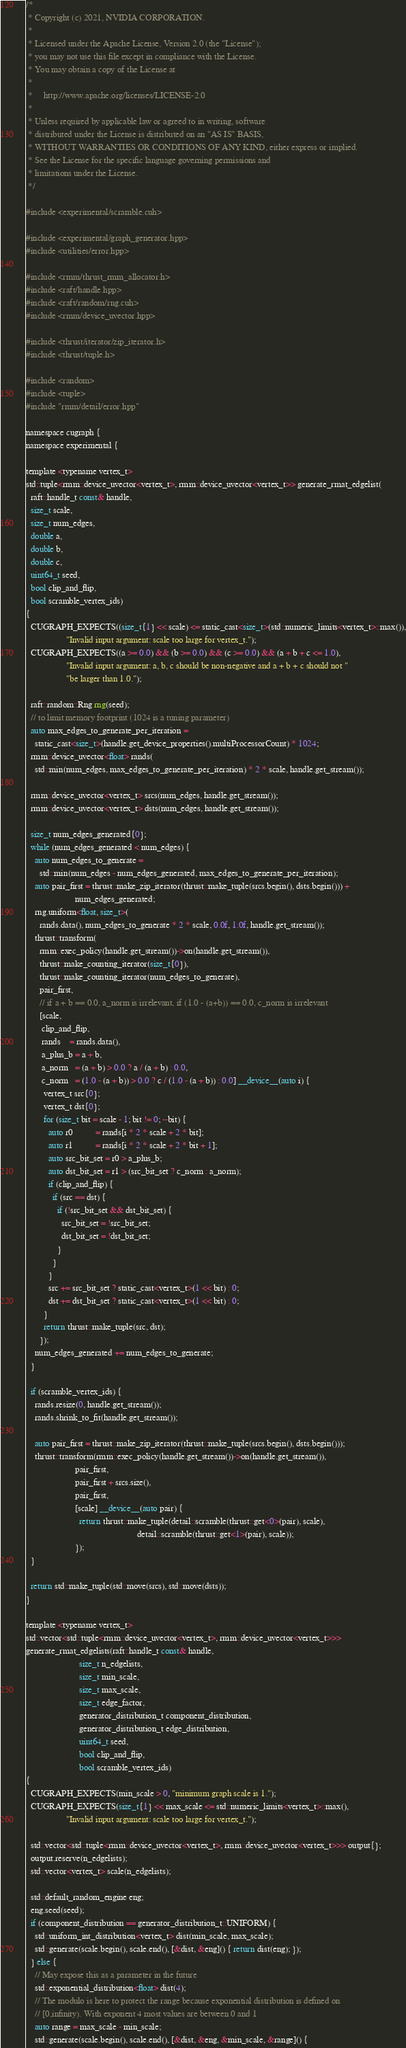<code> <loc_0><loc_0><loc_500><loc_500><_Cuda_>/*
 * Copyright (c) 2021, NVIDIA CORPORATION.
 *
 * Licensed under the Apache License, Version 2.0 (the "License");
 * you may not use this file except in compliance with the License.
 * You may obtain a copy of the License at
 *
 *     http://www.apache.org/licenses/LICENSE-2.0
 *
 * Unless required by applicable law or agreed to in writing, software
 * distributed under the License is distributed on an "AS IS" BASIS,
 * WITHOUT WARRANTIES OR CONDITIONS OF ANY KIND, either express or implied.
 * See the License for the specific language governing permissions and
 * limitations under the License.
 */

#include <experimental/scramble.cuh>

#include <experimental/graph_generator.hpp>
#include <utilities/error.hpp>

#include <rmm/thrust_rmm_allocator.h>
#include <raft/handle.hpp>
#include <raft/random/rng.cuh>
#include <rmm/device_uvector.hpp>

#include <thrust/iterator/zip_iterator.h>
#include <thrust/tuple.h>

#include <random>
#include <tuple>
#include "rmm/detail/error.hpp"

namespace cugraph {
namespace experimental {

template <typename vertex_t>
std::tuple<rmm::device_uvector<vertex_t>, rmm::device_uvector<vertex_t>> generate_rmat_edgelist(
  raft::handle_t const& handle,
  size_t scale,
  size_t num_edges,
  double a,
  double b,
  double c,
  uint64_t seed,
  bool clip_and_flip,
  bool scramble_vertex_ids)
{
  CUGRAPH_EXPECTS((size_t{1} << scale) <= static_cast<size_t>(std::numeric_limits<vertex_t>::max()),
                  "Invalid input argument: scale too large for vertex_t.");
  CUGRAPH_EXPECTS((a >= 0.0) && (b >= 0.0) && (c >= 0.0) && (a + b + c <= 1.0),
                  "Invalid input argument: a, b, c should be non-negative and a + b + c should not "
                  "be larger than 1.0.");

  raft::random::Rng rng(seed);
  // to limit memory footprint (1024 is a tuning parameter)
  auto max_edges_to_generate_per_iteration =
    static_cast<size_t>(handle.get_device_properties().multiProcessorCount) * 1024;
  rmm::device_uvector<float> rands(
    std::min(num_edges, max_edges_to_generate_per_iteration) * 2 * scale, handle.get_stream());

  rmm::device_uvector<vertex_t> srcs(num_edges, handle.get_stream());
  rmm::device_uvector<vertex_t> dsts(num_edges, handle.get_stream());

  size_t num_edges_generated{0};
  while (num_edges_generated < num_edges) {
    auto num_edges_to_generate =
      std::min(num_edges - num_edges_generated, max_edges_to_generate_per_iteration);
    auto pair_first = thrust::make_zip_iterator(thrust::make_tuple(srcs.begin(), dsts.begin())) +
                      num_edges_generated;
    rng.uniform<float, size_t>(
      rands.data(), num_edges_to_generate * 2 * scale, 0.0f, 1.0f, handle.get_stream());
    thrust::transform(
      rmm::exec_policy(handle.get_stream())->on(handle.get_stream()),
      thrust::make_counting_iterator(size_t{0}),
      thrust::make_counting_iterator(num_edges_to_generate),
      pair_first,
      // if a + b == 0.0, a_norm is irrelevant, if (1.0 - (a+b)) == 0.0, c_norm is irrelevant
      [scale,
       clip_and_flip,
       rands    = rands.data(),
       a_plus_b = a + b,
       a_norm   = (a + b) > 0.0 ? a / (a + b) : 0.0,
       c_norm   = (1.0 - (a + b)) > 0.0 ? c / (1.0 - (a + b)) : 0.0] __device__(auto i) {
        vertex_t src{0};
        vertex_t dst{0};
        for (size_t bit = scale - 1; bit != 0; --bit) {
          auto r0          = rands[i * 2 * scale + 2 * bit];
          auto r1          = rands[i * 2 * scale + 2 * bit + 1];
          auto src_bit_set = r0 > a_plus_b;
          auto dst_bit_set = r1 > (src_bit_set ? c_norm : a_norm);
          if (clip_and_flip) {
            if (src == dst) {
              if (!src_bit_set && dst_bit_set) {
                src_bit_set = !src_bit_set;
                dst_bit_set = !dst_bit_set;
              }
            }
          }
          src += src_bit_set ? static_cast<vertex_t>(1 << bit) : 0;
          dst += dst_bit_set ? static_cast<vertex_t>(1 << bit) : 0;
        }
        return thrust::make_tuple(src, dst);
      });
    num_edges_generated += num_edges_to_generate;
  }

  if (scramble_vertex_ids) {
    rands.resize(0, handle.get_stream());
    rands.shrink_to_fit(handle.get_stream());

    auto pair_first = thrust::make_zip_iterator(thrust::make_tuple(srcs.begin(), dsts.begin()));
    thrust::transform(rmm::exec_policy(handle.get_stream())->on(handle.get_stream()),
                      pair_first,
                      pair_first + srcs.size(),
                      pair_first,
                      [scale] __device__(auto pair) {
                        return thrust::make_tuple(detail::scramble(thrust::get<0>(pair), scale),
                                                  detail::scramble(thrust::get<1>(pair), scale));
                      });
  }

  return std::make_tuple(std::move(srcs), std::move(dsts));
}

template <typename vertex_t>
std::vector<std::tuple<rmm::device_uvector<vertex_t>, rmm::device_uvector<vertex_t>>>
generate_rmat_edgelists(raft::handle_t const& handle,
                        size_t n_edgelists,
                        size_t min_scale,
                        size_t max_scale,
                        size_t edge_factor,
                        generator_distribution_t component_distribution,
                        generator_distribution_t edge_distribution,
                        uint64_t seed,
                        bool clip_and_flip,
                        bool scramble_vertex_ids)
{
  CUGRAPH_EXPECTS(min_scale > 0, "minimum graph scale is 1.");
  CUGRAPH_EXPECTS(size_t{1} << max_scale <= std::numeric_limits<vertex_t>::max(),
                  "Invalid input argument: scale too large for vertex_t.");

  std::vector<std::tuple<rmm::device_uvector<vertex_t>, rmm::device_uvector<vertex_t>>> output{};
  output.reserve(n_edgelists);
  std::vector<vertex_t> scale(n_edgelists);

  std::default_random_engine eng;
  eng.seed(seed);
  if (component_distribution == generator_distribution_t::UNIFORM) {
    std::uniform_int_distribution<vertex_t> dist(min_scale, max_scale);
    std::generate(scale.begin(), scale.end(), [&dist, &eng]() { return dist(eng); });
  } else {
    // May expose this as a parameter in the future
    std::exponential_distribution<float> dist(4);
    // The modulo is here to protect the range because exponential distribution is defined on
    // [0,infinity). With exponent 4 most values are between 0 and 1
    auto range = max_scale - min_scale;
    std::generate(scale.begin(), scale.end(), [&dist, &eng, &min_scale, &range]() {</code> 